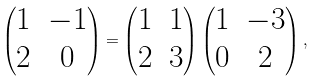Convert formula to latex. <formula><loc_0><loc_0><loc_500><loc_500>\begin{pmatrix} 1 & - 1 \\ 2 & 0 \end{pmatrix} = \begin{pmatrix} 1 & 1 \\ 2 & 3 \end{pmatrix} \begin{pmatrix} 1 & - 3 \\ 0 & 2 \end{pmatrix} ,</formula> 